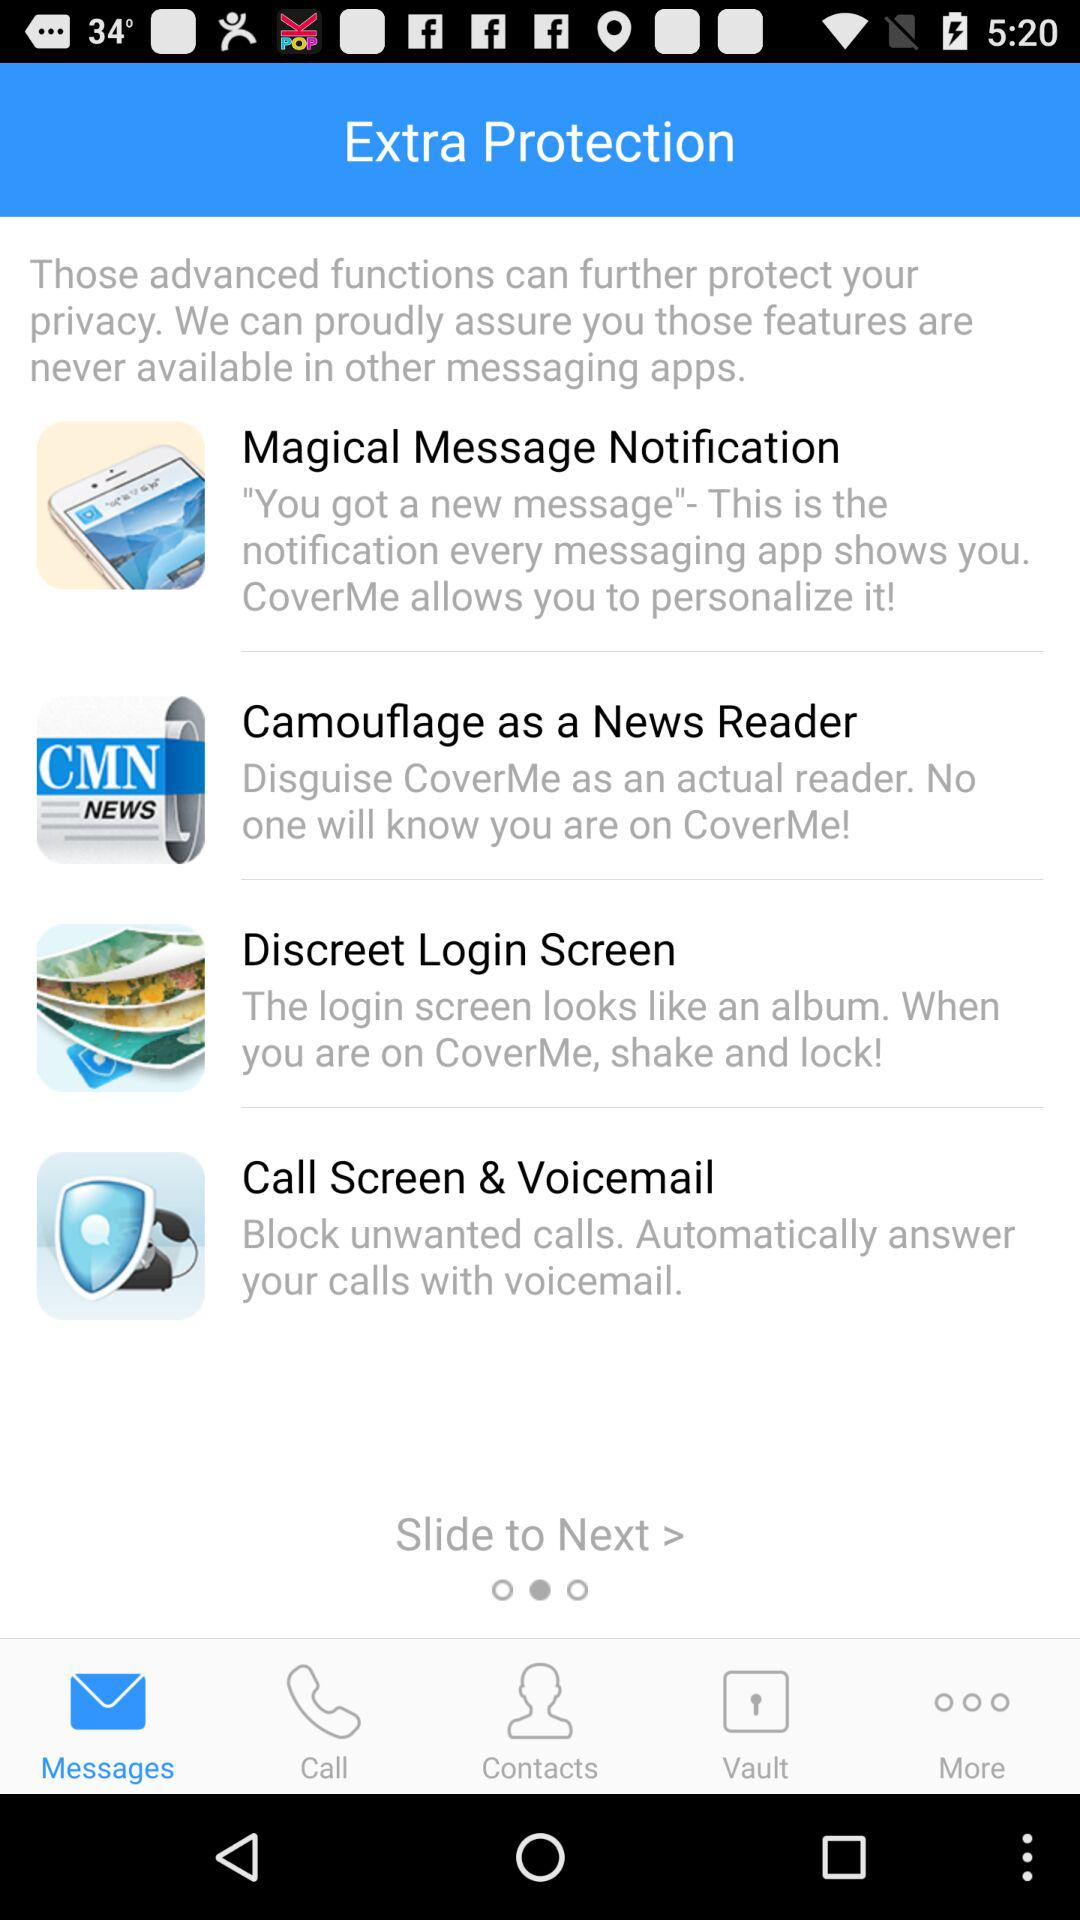Which tab is selected? The selected tab is "Messages". 